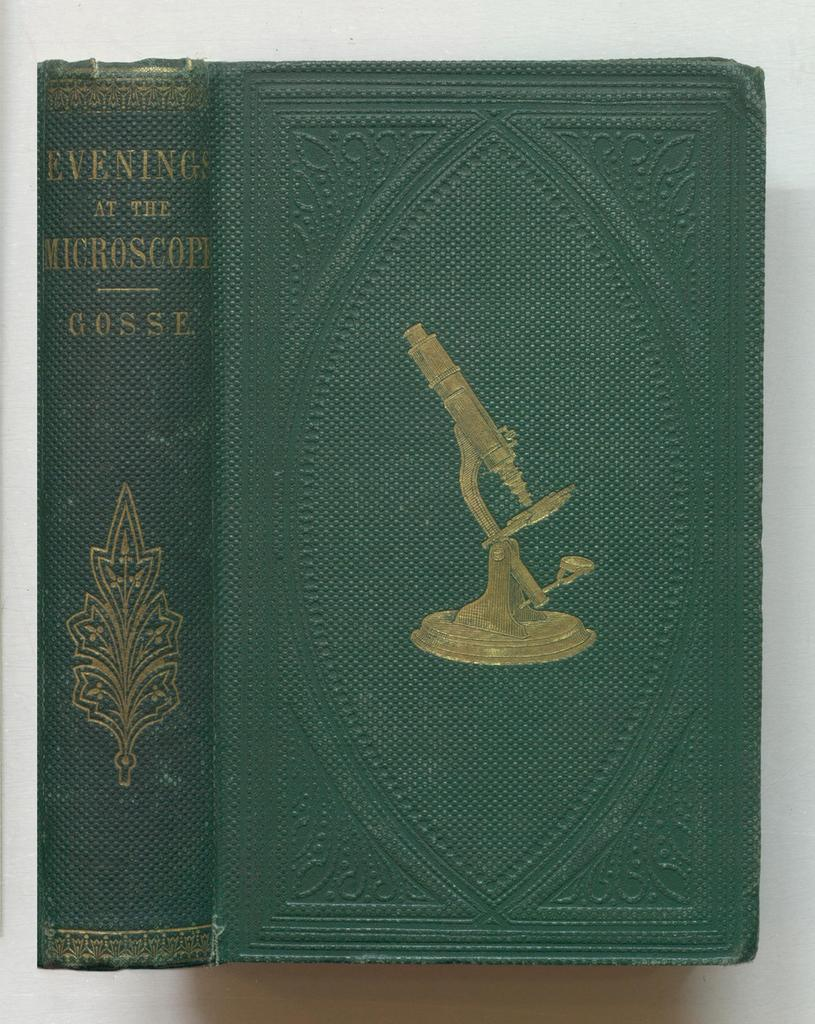<image>
Create a compact narrative representing the image presented. The green cover for the book titled Evening at the microscope by cosse. 